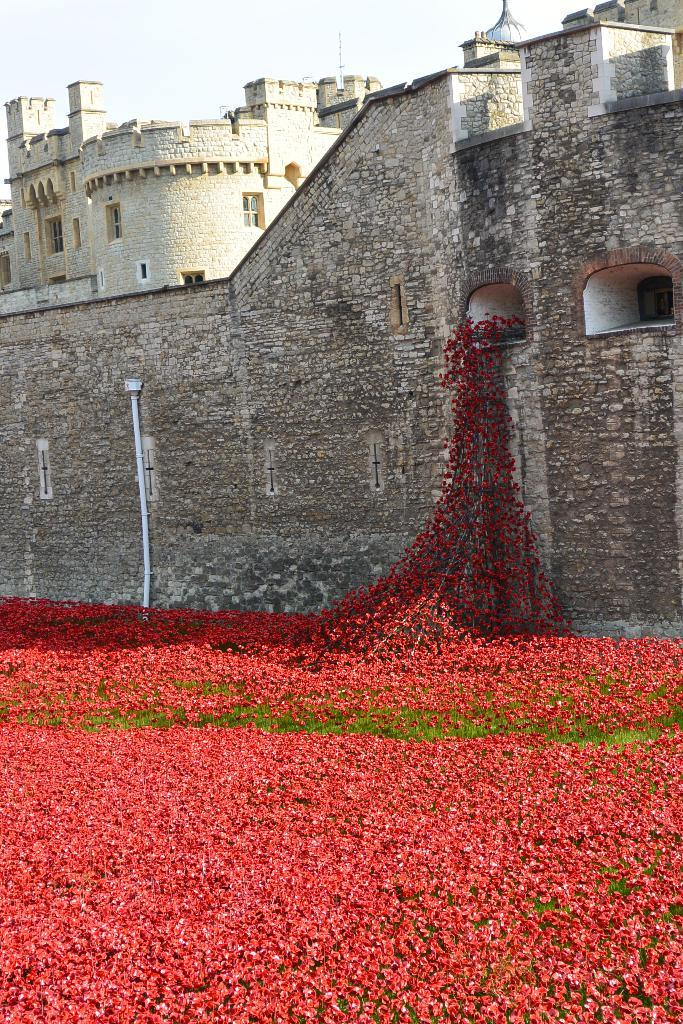What is the main structure in the image? There is a castle in the image. What can be seen on the walls of the castle? The castle has creepers on the wall. What type of vegetation is present at the bottom of the image? There are plants with flowers at the bottom of the image. What is visible at the top of the image? The sky is visible at the top of the image. How many goldfish can be seen swimming in the castle moat in the image? There are no goldfish present in the image, as it features a castle with creepers on the wall, plants with flowers, and a visible sky. 